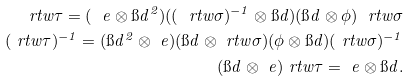Convert formula to latex. <formula><loc_0><loc_0><loc_500><loc_500>\ r t w { \tau } = ( \ e \otimes \i d ^ { 2 } ) ( ( \ r t w { \sigma } ) ^ { - 1 } \otimes \i d ) ( \i d \otimes \phi ) \ r t w { \sigma } \\ ( \ r t w { \tau } ) ^ { - 1 } = ( \i d ^ { 2 } \otimes \ e ) ( \i d \otimes \ r t w { \sigma } ) ( \phi \otimes \i d ) ( \ r t w { \sigma } ) ^ { - 1 } \\ ( \i d \otimes \ e ) \ r t w { \tau } = \ e \otimes \i d .</formula> 